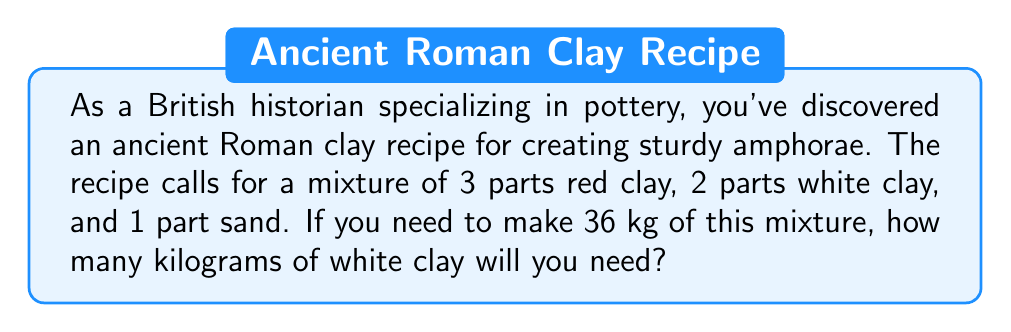Give your solution to this math problem. To solve this problem, we need to follow these steps:

1. Determine the total parts in the mixture:
   Red clay: 3 parts
   White clay: 2 parts
   Sand: 1 part
   Total parts = $3 + 2 + 1 = 6$ parts

2. Calculate the weight of each part:
   Total weight of mixture = 36 kg
   Weight per part = $\frac{\text{Total weight}}{\text{Total parts}} = \frac{36 \text{ kg}}{6} = 6 \text{ kg}$ per part

3. Calculate the weight of white clay:
   White clay is 2 parts of the mixture
   Weight of white clay = $2 \times 6 \text{ kg} = 12 \text{ kg}$

Therefore, you will need 12 kg of white clay to make 36 kg of the ancient Roman clay mixture for amphorae.
Answer: $12 \text{ kg}$ of white clay 